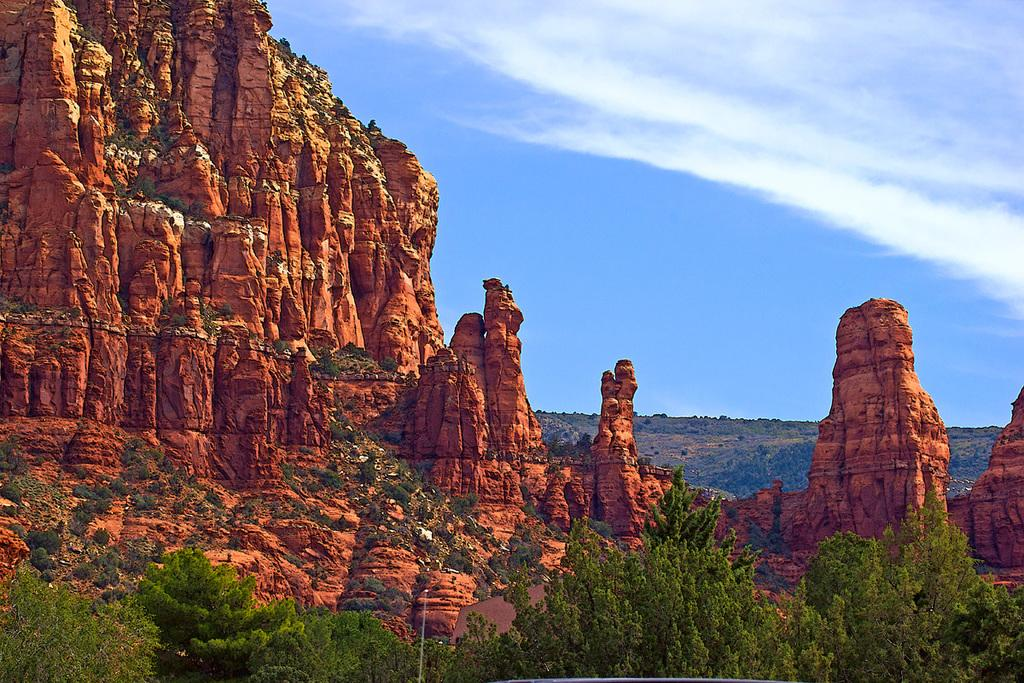What type of vegetation is present in the image? There are many trees in the image. What geographical feature can be seen in the image? There is a mountain in the image, and it is brown. What is visible in the background of the image? There are clouds and the sky in the background of the image. What color is the sky in the image? The sky is blue in the background of the image. Can you see any trains passing through the mountain in the image? There are no trains visible in the image; it only features trees, a brown mountain, clouds, and a blue sky. 